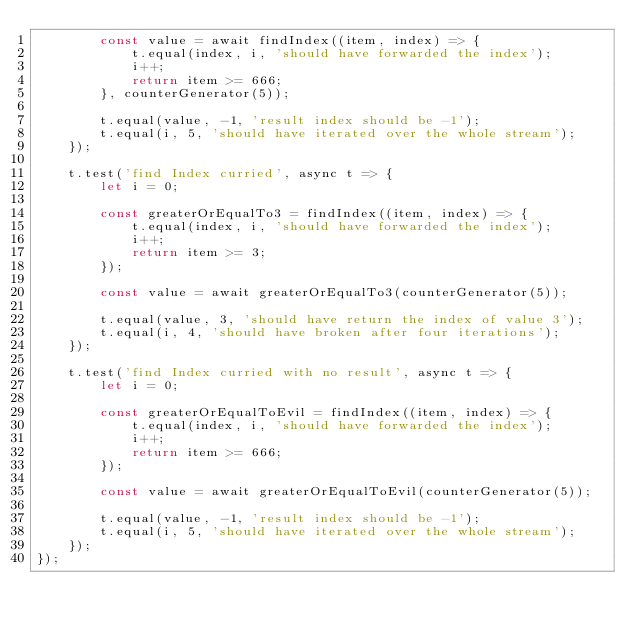<code> <loc_0><loc_0><loc_500><loc_500><_JavaScript_>        const value = await findIndex((item, index) => {
            t.equal(index, i, 'should have forwarded the index');
            i++;
            return item >= 666;
        }, counterGenerator(5));

        t.equal(value, -1, 'result index should be -1');
        t.equal(i, 5, 'should have iterated over the whole stream');
    });

    t.test('find Index curried', async t => {
        let i = 0;

        const greaterOrEqualTo3 = findIndex((item, index) => {
            t.equal(index, i, 'should have forwarded the index');
            i++;
            return item >= 3;
        });

        const value = await greaterOrEqualTo3(counterGenerator(5));

        t.equal(value, 3, 'should have return the index of value 3');
        t.equal(i, 4, 'should have broken after four iterations');
    });

    t.test('find Index curried with no result', async t => {
        let i = 0;

        const greaterOrEqualToEvil = findIndex((item, index) => {
            t.equal(index, i, 'should have forwarded the index');
            i++;
            return item >= 666;
        });

        const value = await greaterOrEqualToEvil(counterGenerator(5));

        t.equal(value, -1, 'result index should be -1');
        t.equal(i, 5, 'should have iterated over the whole stream');
    });
});
</code> 